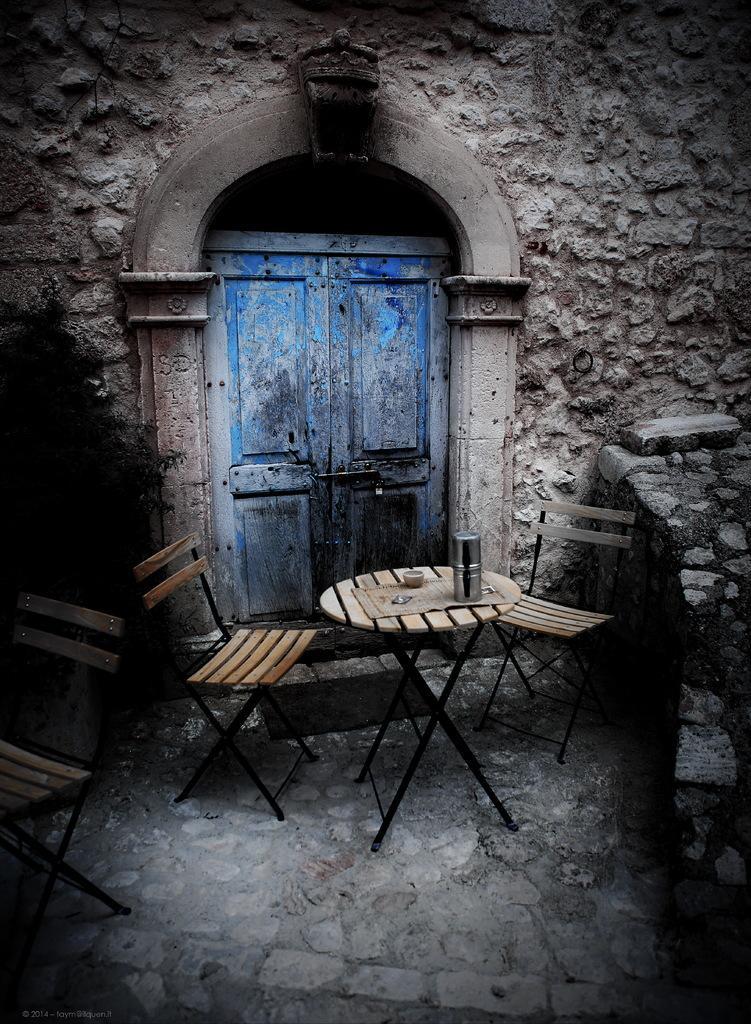Describe this image in one or two sentences. In this image we can see the stone wall and also the door. We can also see the table with chairs and on the table we can see the bowl and also an object. We can also see the stone surface. 